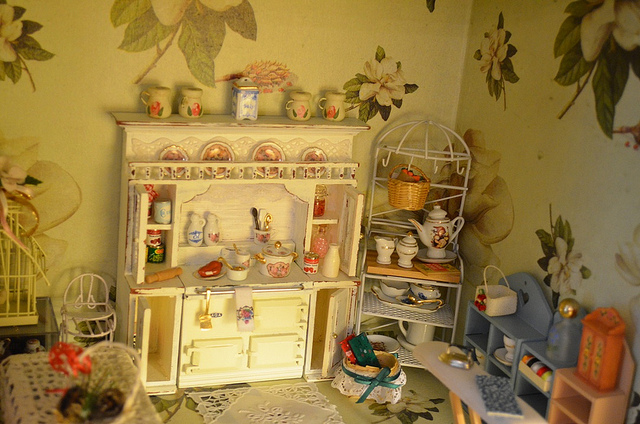How many people are in the picture? There are no people visible in the picture, which instead features a charming miniature room setting with detailed dollhouse furniture and accessories. 